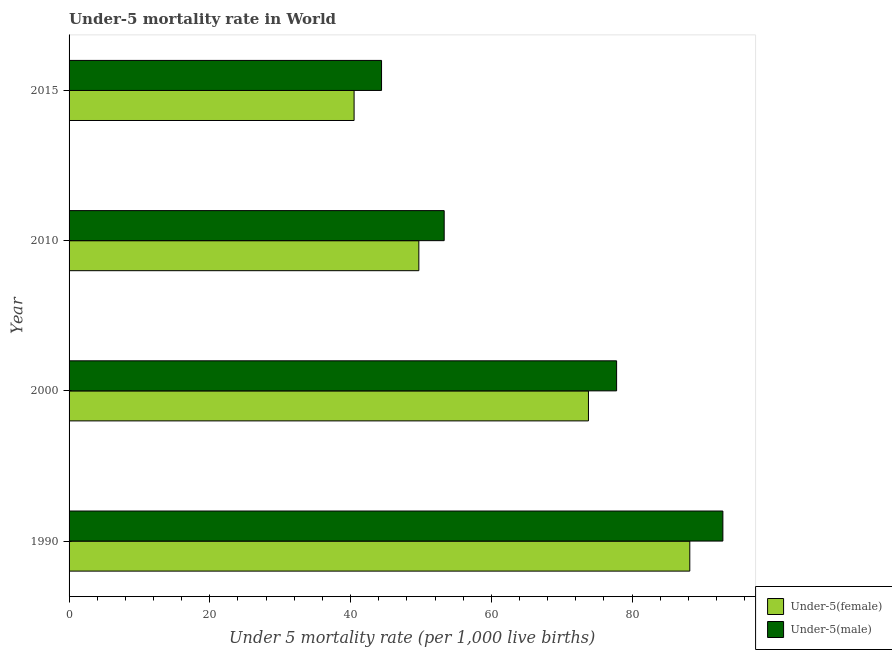How many different coloured bars are there?
Ensure brevity in your answer.  2. How many groups of bars are there?
Ensure brevity in your answer.  4. How many bars are there on the 4th tick from the bottom?
Make the answer very short. 2. What is the label of the 3rd group of bars from the top?
Provide a short and direct response. 2000. What is the under-5 female mortality rate in 2010?
Give a very brief answer. 49.7. Across all years, what is the maximum under-5 female mortality rate?
Offer a terse response. 88.2. Across all years, what is the minimum under-5 female mortality rate?
Ensure brevity in your answer.  40.5. In which year was the under-5 male mortality rate maximum?
Your answer should be very brief. 1990. In which year was the under-5 female mortality rate minimum?
Offer a very short reply. 2015. What is the total under-5 female mortality rate in the graph?
Provide a short and direct response. 252.2. What is the difference between the under-5 male mortality rate in 2010 and the under-5 female mortality rate in 2015?
Offer a very short reply. 12.8. What is the average under-5 male mortality rate per year?
Give a very brief answer. 67.1. In the year 2010, what is the difference between the under-5 female mortality rate and under-5 male mortality rate?
Keep it short and to the point. -3.6. What is the ratio of the under-5 female mortality rate in 2010 to that in 2015?
Make the answer very short. 1.23. Is the difference between the under-5 female mortality rate in 1990 and 2010 greater than the difference between the under-5 male mortality rate in 1990 and 2010?
Ensure brevity in your answer.  No. What is the difference between the highest and the second highest under-5 male mortality rate?
Your response must be concise. 15.1. What is the difference between the highest and the lowest under-5 male mortality rate?
Give a very brief answer. 48.5. In how many years, is the under-5 female mortality rate greater than the average under-5 female mortality rate taken over all years?
Keep it short and to the point. 2. What does the 2nd bar from the top in 2010 represents?
Your answer should be compact. Under-5(female). What does the 1st bar from the bottom in 2010 represents?
Offer a terse response. Under-5(female). How many years are there in the graph?
Give a very brief answer. 4. Are the values on the major ticks of X-axis written in scientific E-notation?
Ensure brevity in your answer.  No. Where does the legend appear in the graph?
Ensure brevity in your answer.  Bottom right. What is the title of the graph?
Provide a succinct answer. Under-5 mortality rate in World. Does "2012 US$" appear as one of the legend labels in the graph?
Make the answer very short. No. What is the label or title of the X-axis?
Make the answer very short. Under 5 mortality rate (per 1,0 live births). What is the Under 5 mortality rate (per 1,000 live births) of Under-5(female) in 1990?
Your response must be concise. 88.2. What is the Under 5 mortality rate (per 1,000 live births) in Under-5(male) in 1990?
Keep it short and to the point. 92.9. What is the Under 5 mortality rate (per 1,000 live births) in Under-5(female) in 2000?
Offer a very short reply. 73.8. What is the Under 5 mortality rate (per 1,000 live births) in Under-5(male) in 2000?
Make the answer very short. 77.8. What is the Under 5 mortality rate (per 1,000 live births) in Under-5(female) in 2010?
Keep it short and to the point. 49.7. What is the Under 5 mortality rate (per 1,000 live births) in Under-5(male) in 2010?
Your response must be concise. 53.3. What is the Under 5 mortality rate (per 1,000 live births) of Under-5(female) in 2015?
Your answer should be compact. 40.5. What is the Under 5 mortality rate (per 1,000 live births) in Under-5(male) in 2015?
Your answer should be compact. 44.4. Across all years, what is the maximum Under 5 mortality rate (per 1,000 live births) in Under-5(female)?
Offer a terse response. 88.2. Across all years, what is the maximum Under 5 mortality rate (per 1,000 live births) of Under-5(male)?
Your response must be concise. 92.9. Across all years, what is the minimum Under 5 mortality rate (per 1,000 live births) in Under-5(female)?
Offer a terse response. 40.5. Across all years, what is the minimum Under 5 mortality rate (per 1,000 live births) of Under-5(male)?
Offer a very short reply. 44.4. What is the total Under 5 mortality rate (per 1,000 live births) in Under-5(female) in the graph?
Offer a terse response. 252.2. What is the total Under 5 mortality rate (per 1,000 live births) in Under-5(male) in the graph?
Offer a very short reply. 268.4. What is the difference between the Under 5 mortality rate (per 1,000 live births) in Under-5(female) in 1990 and that in 2000?
Provide a succinct answer. 14.4. What is the difference between the Under 5 mortality rate (per 1,000 live births) in Under-5(female) in 1990 and that in 2010?
Provide a short and direct response. 38.5. What is the difference between the Under 5 mortality rate (per 1,000 live births) of Under-5(male) in 1990 and that in 2010?
Provide a short and direct response. 39.6. What is the difference between the Under 5 mortality rate (per 1,000 live births) in Under-5(female) in 1990 and that in 2015?
Your answer should be very brief. 47.7. What is the difference between the Under 5 mortality rate (per 1,000 live births) in Under-5(male) in 1990 and that in 2015?
Give a very brief answer. 48.5. What is the difference between the Under 5 mortality rate (per 1,000 live births) in Under-5(female) in 2000 and that in 2010?
Your response must be concise. 24.1. What is the difference between the Under 5 mortality rate (per 1,000 live births) in Under-5(male) in 2000 and that in 2010?
Provide a short and direct response. 24.5. What is the difference between the Under 5 mortality rate (per 1,000 live births) of Under-5(female) in 2000 and that in 2015?
Offer a terse response. 33.3. What is the difference between the Under 5 mortality rate (per 1,000 live births) of Under-5(male) in 2000 and that in 2015?
Offer a terse response. 33.4. What is the difference between the Under 5 mortality rate (per 1,000 live births) of Under-5(female) in 2010 and that in 2015?
Your answer should be compact. 9.2. What is the difference between the Under 5 mortality rate (per 1,000 live births) of Under-5(male) in 2010 and that in 2015?
Keep it short and to the point. 8.9. What is the difference between the Under 5 mortality rate (per 1,000 live births) in Under-5(female) in 1990 and the Under 5 mortality rate (per 1,000 live births) in Under-5(male) in 2010?
Keep it short and to the point. 34.9. What is the difference between the Under 5 mortality rate (per 1,000 live births) in Under-5(female) in 1990 and the Under 5 mortality rate (per 1,000 live births) in Under-5(male) in 2015?
Offer a terse response. 43.8. What is the difference between the Under 5 mortality rate (per 1,000 live births) in Under-5(female) in 2000 and the Under 5 mortality rate (per 1,000 live births) in Under-5(male) in 2015?
Provide a succinct answer. 29.4. What is the difference between the Under 5 mortality rate (per 1,000 live births) in Under-5(female) in 2010 and the Under 5 mortality rate (per 1,000 live births) in Under-5(male) in 2015?
Your answer should be very brief. 5.3. What is the average Under 5 mortality rate (per 1,000 live births) in Under-5(female) per year?
Provide a succinct answer. 63.05. What is the average Under 5 mortality rate (per 1,000 live births) in Under-5(male) per year?
Give a very brief answer. 67.1. In the year 1990, what is the difference between the Under 5 mortality rate (per 1,000 live births) in Under-5(female) and Under 5 mortality rate (per 1,000 live births) in Under-5(male)?
Provide a succinct answer. -4.7. In the year 2000, what is the difference between the Under 5 mortality rate (per 1,000 live births) in Under-5(female) and Under 5 mortality rate (per 1,000 live births) in Under-5(male)?
Ensure brevity in your answer.  -4. In the year 2010, what is the difference between the Under 5 mortality rate (per 1,000 live births) of Under-5(female) and Under 5 mortality rate (per 1,000 live births) of Under-5(male)?
Offer a terse response. -3.6. What is the ratio of the Under 5 mortality rate (per 1,000 live births) in Under-5(female) in 1990 to that in 2000?
Make the answer very short. 1.2. What is the ratio of the Under 5 mortality rate (per 1,000 live births) of Under-5(male) in 1990 to that in 2000?
Give a very brief answer. 1.19. What is the ratio of the Under 5 mortality rate (per 1,000 live births) of Under-5(female) in 1990 to that in 2010?
Offer a very short reply. 1.77. What is the ratio of the Under 5 mortality rate (per 1,000 live births) in Under-5(male) in 1990 to that in 2010?
Your response must be concise. 1.74. What is the ratio of the Under 5 mortality rate (per 1,000 live births) in Under-5(female) in 1990 to that in 2015?
Provide a succinct answer. 2.18. What is the ratio of the Under 5 mortality rate (per 1,000 live births) of Under-5(male) in 1990 to that in 2015?
Your answer should be very brief. 2.09. What is the ratio of the Under 5 mortality rate (per 1,000 live births) of Under-5(female) in 2000 to that in 2010?
Offer a very short reply. 1.48. What is the ratio of the Under 5 mortality rate (per 1,000 live births) in Under-5(male) in 2000 to that in 2010?
Your answer should be very brief. 1.46. What is the ratio of the Under 5 mortality rate (per 1,000 live births) of Under-5(female) in 2000 to that in 2015?
Your answer should be compact. 1.82. What is the ratio of the Under 5 mortality rate (per 1,000 live births) in Under-5(male) in 2000 to that in 2015?
Give a very brief answer. 1.75. What is the ratio of the Under 5 mortality rate (per 1,000 live births) of Under-5(female) in 2010 to that in 2015?
Your response must be concise. 1.23. What is the ratio of the Under 5 mortality rate (per 1,000 live births) in Under-5(male) in 2010 to that in 2015?
Offer a terse response. 1.2. What is the difference between the highest and the lowest Under 5 mortality rate (per 1,000 live births) in Under-5(female)?
Ensure brevity in your answer.  47.7. What is the difference between the highest and the lowest Under 5 mortality rate (per 1,000 live births) of Under-5(male)?
Your response must be concise. 48.5. 